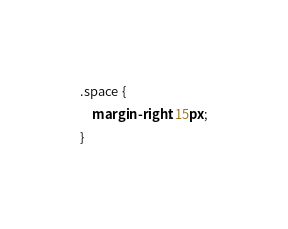<code> <loc_0><loc_0><loc_500><loc_500><_CSS_>.space {
    margin-right: 15px;
}
</code> 